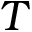Convert formula to latex. <formula><loc_0><loc_0><loc_500><loc_500>T</formula> 